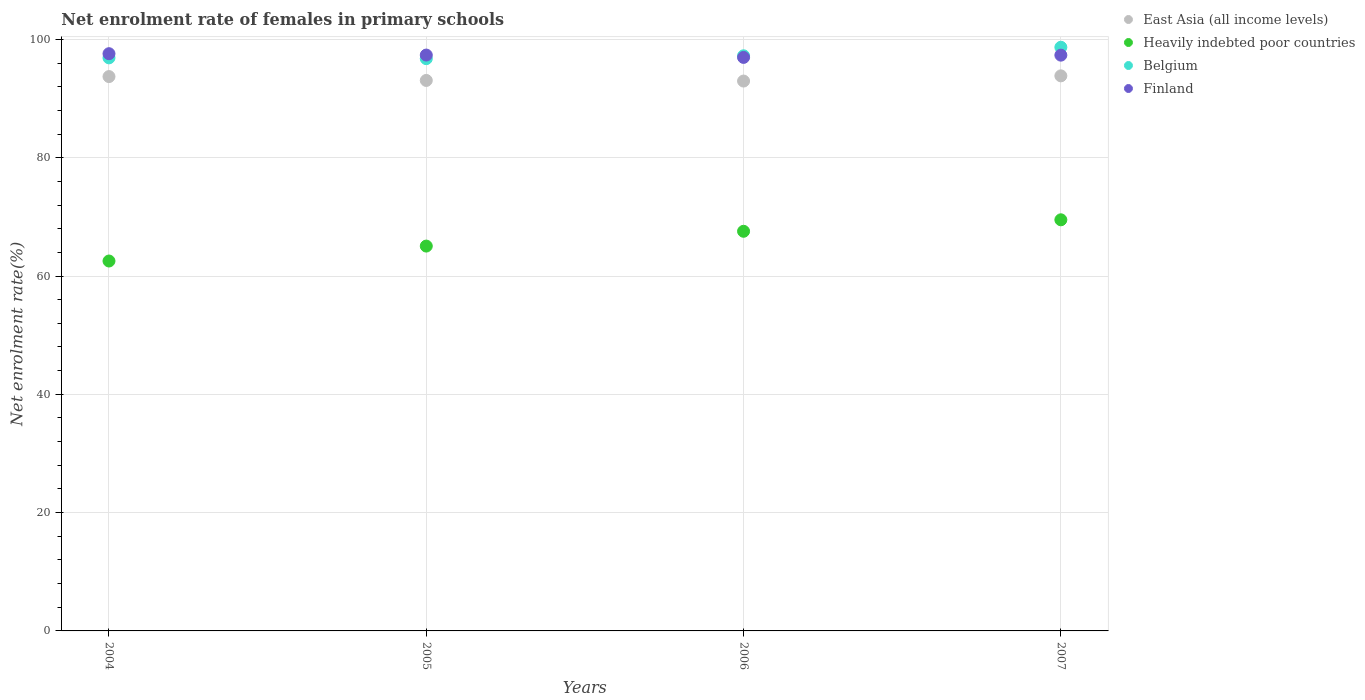What is the net enrolment rate of females in primary schools in East Asia (all income levels) in 2006?
Your response must be concise. 92.96. Across all years, what is the maximum net enrolment rate of females in primary schools in Finland?
Your response must be concise. 97.58. Across all years, what is the minimum net enrolment rate of females in primary schools in Belgium?
Your answer should be very brief. 96.75. In which year was the net enrolment rate of females in primary schools in East Asia (all income levels) maximum?
Ensure brevity in your answer.  2007. In which year was the net enrolment rate of females in primary schools in East Asia (all income levels) minimum?
Give a very brief answer. 2006. What is the total net enrolment rate of females in primary schools in East Asia (all income levels) in the graph?
Give a very brief answer. 373.57. What is the difference between the net enrolment rate of females in primary schools in Heavily indebted poor countries in 2004 and that in 2006?
Provide a short and direct response. -5.03. What is the difference between the net enrolment rate of females in primary schools in Belgium in 2006 and the net enrolment rate of females in primary schools in East Asia (all income levels) in 2005?
Offer a very short reply. 4.17. What is the average net enrolment rate of females in primary schools in East Asia (all income levels) per year?
Offer a very short reply. 93.39. In the year 2005, what is the difference between the net enrolment rate of females in primary schools in Belgium and net enrolment rate of females in primary schools in East Asia (all income levels)?
Give a very brief answer. 3.68. What is the ratio of the net enrolment rate of females in primary schools in Finland in 2004 to that in 2007?
Ensure brevity in your answer.  1. What is the difference between the highest and the second highest net enrolment rate of females in primary schools in Belgium?
Keep it short and to the point. 1.44. What is the difference between the highest and the lowest net enrolment rate of females in primary schools in East Asia (all income levels)?
Your answer should be compact. 0.88. Is it the case that in every year, the sum of the net enrolment rate of females in primary schools in East Asia (all income levels) and net enrolment rate of females in primary schools in Heavily indebted poor countries  is greater than the sum of net enrolment rate of females in primary schools in Belgium and net enrolment rate of females in primary schools in Finland?
Your answer should be compact. No. Is it the case that in every year, the sum of the net enrolment rate of females in primary schools in Belgium and net enrolment rate of females in primary schools in East Asia (all income levels)  is greater than the net enrolment rate of females in primary schools in Finland?
Your answer should be compact. Yes. How many years are there in the graph?
Your answer should be compact. 4. What is the difference between two consecutive major ticks on the Y-axis?
Provide a succinct answer. 20. Are the values on the major ticks of Y-axis written in scientific E-notation?
Ensure brevity in your answer.  No. Does the graph contain grids?
Offer a terse response. Yes. What is the title of the graph?
Provide a succinct answer. Net enrolment rate of females in primary schools. What is the label or title of the X-axis?
Your answer should be compact. Years. What is the label or title of the Y-axis?
Offer a terse response. Net enrolment rate(%). What is the Net enrolment rate(%) in East Asia (all income levels) in 2004?
Offer a very short reply. 93.72. What is the Net enrolment rate(%) of Heavily indebted poor countries in 2004?
Provide a short and direct response. 62.54. What is the Net enrolment rate(%) in Belgium in 2004?
Provide a short and direct response. 96.88. What is the Net enrolment rate(%) of Finland in 2004?
Your answer should be very brief. 97.58. What is the Net enrolment rate(%) of East Asia (all income levels) in 2005?
Provide a short and direct response. 93.06. What is the Net enrolment rate(%) in Heavily indebted poor countries in 2005?
Give a very brief answer. 65.06. What is the Net enrolment rate(%) of Belgium in 2005?
Your answer should be compact. 96.75. What is the Net enrolment rate(%) of Finland in 2005?
Give a very brief answer. 97.35. What is the Net enrolment rate(%) of East Asia (all income levels) in 2006?
Your response must be concise. 92.96. What is the Net enrolment rate(%) of Heavily indebted poor countries in 2006?
Your response must be concise. 67.56. What is the Net enrolment rate(%) in Belgium in 2006?
Offer a terse response. 97.23. What is the Net enrolment rate(%) of Finland in 2006?
Your answer should be compact. 96.96. What is the Net enrolment rate(%) of East Asia (all income levels) in 2007?
Offer a terse response. 93.84. What is the Net enrolment rate(%) in Heavily indebted poor countries in 2007?
Keep it short and to the point. 69.5. What is the Net enrolment rate(%) in Belgium in 2007?
Your response must be concise. 98.67. What is the Net enrolment rate(%) in Finland in 2007?
Your answer should be compact. 97.34. Across all years, what is the maximum Net enrolment rate(%) of East Asia (all income levels)?
Provide a succinct answer. 93.84. Across all years, what is the maximum Net enrolment rate(%) in Heavily indebted poor countries?
Your response must be concise. 69.5. Across all years, what is the maximum Net enrolment rate(%) in Belgium?
Ensure brevity in your answer.  98.67. Across all years, what is the maximum Net enrolment rate(%) of Finland?
Offer a terse response. 97.58. Across all years, what is the minimum Net enrolment rate(%) in East Asia (all income levels)?
Your response must be concise. 92.96. Across all years, what is the minimum Net enrolment rate(%) in Heavily indebted poor countries?
Your response must be concise. 62.54. Across all years, what is the minimum Net enrolment rate(%) in Belgium?
Offer a terse response. 96.75. Across all years, what is the minimum Net enrolment rate(%) of Finland?
Keep it short and to the point. 96.96. What is the total Net enrolment rate(%) of East Asia (all income levels) in the graph?
Keep it short and to the point. 373.57. What is the total Net enrolment rate(%) in Heavily indebted poor countries in the graph?
Provide a short and direct response. 264.66. What is the total Net enrolment rate(%) of Belgium in the graph?
Your answer should be very brief. 389.53. What is the total Net enrolment rate(%) in Finland in the graph?
Offer a very short reply. 389.23. What is the difference between the Net enrolment rate(%) of East Asia (all income levels) in 2004 and that in 2005?
Offer a terse response. 0.65. What is the difference between the Net enrolment rate(%) in Heavily indebted poor countries in 2004 and that in 2005?
Your answer should be very brief. -2.52. What is the difference between the Net enrolment rate(%) in Belgium in 2004 and that in 2005?
Your answer should be compact. 0.13. What is the difference between the Net enrolment rate(%) of Finland in 2004 and that in 2005?
Provide a short and direct response. 0.23. What is the difference between the Net enrolment rate(%) in East Asia (all income levels) in 2004 and that in 2006?
Offer a very short reply. 0.76. What is the difference between the Net enrolment rate(%) of Heavily indebted poor countries in 2004 and that in 2006?
Keep it short and to the point. -5.03. What is the difference between the Net enrolment rate(%) of Belgium in 2004 and that in 2006?
Offer a very short reply. -0.35. What is the difference between the Net enrolment rate(%) of Finland in 2004 and that in 2006?
Provide a short and direct response. 0.63. What is the difference between the Net enrolment rate(%) in East Asia (all income levels) in 2004 and that in 2007?
Provide a short and direct response. -0.12. What is the difference between the Net enrolment rate(%) of Heavily indebted poor countries in 2004 and that in 2007?
Offer a very short reply. -6.97. What is the difference between the Net enrolment rate(%) in Belgium in 2004 and that in 2007?
Offer a very short reply. -1.79. What is the difference between the Net enrolment rate(%) of Finland in 2004 and that in 2007?
Make the answer very short. 0.25. What is the difference between the Net enrolment rate(%) of East Asia (all income levels) in 2005 and that in 2006?
Ensure brevity in your answer.  0.1. What is the difference between the Net enrolment rate(%) of Heavily indebted poor countries in 2005 and that in 2006?
Provide a succinct answer. -2.5. What is the difference between the Net enrolment rate(%) in Belgium in 2005 and that in 2006?
Provide a succinct answer. -0.48. What is the difference between the Net enrolment rate(%) in Finland in 2005 and that in 2006?
Ensure brevity in your answer.  0.4. What is the difference between the Net enrolment rate(%) in East Asia (all income levels) in 2005 and that in 2007?
Give a very brief answer. -0.78. What is the difference between the Net enrolment rate(%) in Heavily indebted poor countries in 2005 and that in 2007?
Your answer should be very brief. -4.44. What is the difference between the Net enrolment rate(%) in Belgium in 2005 and that in 2007?
Provide a succinct answer. -1.93. What is the difference between the Net enrolment rate(%) in Finland in 2005 and that in 2007?
Your response must be concise. 0.02. What is the difference between the Net enrolment rate(%) of East Asia (all income levels) in 2006 and that in 2007?
Your answer should be very brief. -0.88. What is the difference between the Net enrolment rate(%) in Heavily indebted poor countries in 2006 and that in 2007?
Offer a terse response. -1.94. What is the difference between the Net enrolment rate(%) of Belgium in 2006 and that in 2007?
Your response must be concise. -1.44. What is the difference between the Net enrolment rate(%) in Finland in 2006 and that in 2007?
Offer a terse response. -0.38. What is the difference between the Net enrolment rate(%) in East Asia (all income levels) in 2004 and the Net enrolment rate(%) in Heavily indebted poor countries in 2005?
Your answer should be very brief. 28.65. What is the difference between the Net enrolment rate(%) of East Asia (all income levels) in 2004 and the Net enrolment rate(%) of Belgium in 2005?
Offer a terse response. -3.03. What is the difference between the Net enrolment rate(%) of East Asia (all income levels) in 2004 and the Net enrolment rate(%) of Finland in 2005?
Your answer should be compact. -3.64. What is the difference between the Net enrolment rate(%) in Heavily indebted poor countries in 2004 and the Net enrolment rate(%) in Belgium in 2005?
Your answer should be compact. -34.21. What is the difference between the Net enrolment rate(%) in Heavily indebted poor countries in 2004 and the Net enrolment rate(%) in Finland in 2005?
Provide a short and direct response. -34.82. What is the difference between the Net enrolment rate(%) in Belgium in 2004 and the Net enrolment rate(%) in Finland in 2005?
Your answer should be compact. -0.47. What is the difference between the Net enrolment rate(%) of East Asia (all income levels) in 2004 and the Net enrolment rate(%) of Heavily indebted poor countries in 2006?
Provide a short and direct response. 26.15. What is the difference between the Net enrolment rate(%) of East Asia (all income levels) in 2004 and the Net enrolment rate(%) of Belgium in 2006?
Give a very brief answer. -3.51. What is the difference between the Net enrolment rate(%) in East Asia (all income levels) in 2004 and the Net enrolment rate(%) in Finland in 2006?
Offer a terse response. -3.24. What is the difference between the Net enrolment rate(%) in Heavily indebted poor countries in 2004 and the Net enrolment rate(%) in Belgium in 2006?
Offer a terse response. -34.69. What is the difference between the Net enrolment rate(%) in Heavily indebted poor countries in 2004 and the Net enrolment rate(%) in Finland in 2006?
Your answer should be compact. -34.42. What is the difference between the Net enrolment rate(%) of Belgium in 2004 and the Net enrolment rate(%) of Finland in 2006?
Make the answer very short. -0.08. What is the difference between the Net enrolment rate(%) in East Asia (all income levels) in 2004 and the Net enrolment rate(%) in Heavily indebted poor countries in 2007?
Ensure brevity in your answer.  24.21. What is the difference between the Net enrolment rate(%) of East Asia (all income levels) in 2004 and the Net enrolment rate(%) of Belgium in 2007?
Give a very brief answer. -4.96. What is the difference between the Net enrolment rate(%) in East Asia (all income levels) in 2004 and the Net enrolment rate(%) in Finland in 2007?
Make the answer very short. -3.62. What is the difference between the Net enrolment rate(%) in Heavily indebted poor countries in 2004 and the Net enrolment rate(%) in Belgium in 2007?
Give a very brief answer. -36.14. What is the difference between the Net enrolment rate(%) of Heavily indebted poor countries in 2004 and the Net enrolment rate(%) of Finland in 2007?
Offer a very short reply. -34.8. What is the difference between the Net enrolment rate(%) in Belgium in 2004 and the Net enrolment rate(%) in Finland in 2007?
Your answer should be compact. -0.46. What is the difference between the Net enrolment rate(%) of East Asia (all income levels) in 2005 and the Net enrolment rate(%) of Heavily indebted poor countries in 2006?
Keep it short and to the point. 25.5. What is the difference between the Net enrolment rate(%) in East Asia (all income levels) in 2005 and the Net enrolment rate(%) in Belgium in 2006?
Your answer should be compact. -4.17. What is the difference between the Net enrolment rate(%) of East Asia (all income levels) in 2005 and the Net enrolment rate(%) of Finland in 2006?
Keep it short and to the point. -3.89. What is the difference between the Net enrolment rate(%) of Heavily indebted poor countries in 2005 and the Net enrolment rate(%) of Belgium in 2006?
Your answer should be compact. -32.17. What is the difference between the Net enrolment rate(%) in Heavily indebted poor countries in 2005 and the Net enrolment rate(%) in Finland in 2006?
Offer a terse response. -31.9. What is the difference between the Net enrolment rate(%) of Belgium in 2005 and the Net enrolment rate(%) of Finland in 2006?
Offer a very short reply. -0.21. What is the difference between the Net enrolment rate(%) of East Asia (all income levels) in 2005 and the Net enrolment rate(%) of Heavily indebted poor countries in 2007?
Provide a short and direct response. 23.56. What is the difference between the Net enrolment rate(%) in East Asia (all income levels) in 2005 and the Net enrolment rate(%) in Belgium in 2007?
Give a very brief answer. -5.61. What is the difference between the Net enrolment rate(%) of East Asia (all income levels) in 2005 and the Net enrolment rate(%) of Finland in 2007?
Your answer should be compact. -4.28. What is the difference between the Net enrolment rate(%) of Heavily indebted poor countries in 2005 and the Net enrolment rate(%) of Belgium in 2007?
Your answer should be very brief. -33.61. What is the difference between the Net enrolment rate(%) in Heavily indebted poor countries in 2005 and the Net enrolment rate(%) in Finland in 2007?
Offer a terse response. -32.28. What is the difference between the Net enrolment rate(%) of Belgium in 2005 and the Net enrolment rate(%) of Finland in 2007?
Offer a terse response. -0.59. What is the difference between the Net enrolment rate(%) in East Asia (all income levels) in 2006 and the Net enrolment rate(%) in Heavily indebted poor countries in 2007?
Your response must be concise. 23.46. What is the difference between the Net enrolment rate(%) in East Asia (all income levels) in 2006 and the Net enrolment rate(%) in Belgium in 2007?
Give a very brief answer. -5.71. What is the difference between the Net enrolment rate(%) in East Asia (all income levels) in 2006 and the Net enrolment rate(%) in Finland in 2007?
Keep it short and to the point. -4.38. What is the difference between the Net enrolment rate(%) of Heavily indebted poor countries in 2006 and the Net enrolment rate(%) of Belgium in 2007?
Offer a very short reply. -31.11. What is the difference between the Net enrolment rate(%) of Heavily indebted poor countries in 2006 and the Net enrolment rate(%) of Finland in 2007?
Provide a short and direct response. -29.78. What is the difference between the Net enrolment rate(%) in Belgium in 2006 and the Net enrolment rate(%) in Finland in 2007?
Provide a succinct answer. -0.11. What is the average Net enrolment rate(%) in East Asia (all income levels) per year?
Provide a short and direct response. 93.39. What is the average Net enrolment rate(%) of Heavily indebted poor countries per year?
Keep it short and to the point. 66.17. What is the average Net enrolment rate(%) in Belgium per year?
Make the answer very short. 97.38. What is the average Net enrolment rate(%) of Finland per year?
Ensure brevity in your answer.  97.31. In the year 2004, what is the difference between the Net enrolment rate(%) in East Asia (all income levels) and Net enrolment rate(%) in Heavily indebted poor countries?
Provide a short and direct response. 31.18. In the year 2004, what is the difference between the Net enrolment rate(%) in East Asia (all income levels) and Net enrolment rate(%) in Belgium?
Your answer should be compact. -3.16. In the year 2004, what is the difference between the Net enrolment rate(%) in East Asia (all income levels) and Net enrolment rate(%) in Finland?
Offer a very short reply. -3.87. In the year 2004, what is the difference between the Net enrolment rate(%) in Heavily indebted poor countries and Net enrolment rate(%) in Belgium?
Make the answer very short. -34.34. In the year 2004, what is the difference between the Net enrolment rate(%) of Heavily indebted poor countries and Net enrolment rate(%) of Finland?
Give a very brief answer. -35.05. In the year 2004, what is the difference between the Net enrolment rate(%) in Belgium and Net enrolment rate(%) in Finland?
Give a very brief answer. -0.7. In the year 2005, what is the difference between the Net enrolment rate(%) in East Asia (all income levels) and Net enrolment rate(%) in Heavily indebted poor countries?
Your response must be concise. 28. In the year 2005, what is the difference between the Net enrolment rate(%) in East Asia (all income levels) and Net enrolment rate(%) in Belgium?
Your answer should be compact. -3.68. In the year 2005, what is the difference between the Net enrolment rate(%) of East Asia (all income levels) and Net enrolment rate(%) of Finland?
Provide a short and direct response. -4.29. In the year 2005, what is the difference between the Net enrolment rate(%) in Heavily indebted poor countries and Net enrolment rate(%) in Belgium?
Provide a succinct answer. -31.69. In the year 2005, what is the difference between the Net enrolment rate(%) in Heavily indebted poor countries and Net enrolment rate(%) in Finland?
Provide a short and direct response. -32.29. In the year 2005, what is the difference between the Net enrolment rate(%) of Belgium and Net enrolment rate(%) of Finland?
Provide a succinct answer. -0.61. In the year 2006, what is the difference between the Net enrolment rate(%) of East Asia (all income levels) and Net enrolment rate(%) of Heavily indebted poor countries?
Keep it short and to the point. 25.4. In the year 2006, what is the difference between the Net enrolment rate(%) in East Asia (all income levels) and Net enrolment rate(%) in Belgium?
Your response must be concise. -4.27. In the year 2006, what is the difference between the Net enrolment rate(%) of East Asia (all income levels) and Net enrolment rate(%) of Finland?
Your answer should be very brief. -4. In the year 2006, what is the difference between the Net enrolment rate(%) in Heavily indebted poor countries and Net enrolment rate(%) in Belgium?
Give a very brief answer. -29.67. In the year 2006, what is the difference between the Net enrolment rate(%) of Heavily indebted poor countries and Net enrolment rate(%) of Finland?
Ensure brevity in your answer.  -29.39. In the year 2006, what is the difference between the Net enrolment rate(%) in Belgium and Net enrolment rate(%) in Finland?
Provide a short and direct response. 0.27. In the year 2007, what is the difference between the Net enrolment rate(%) of East Asia (all income levels) and Net enrolment rate(%) of Heavily indebted poor countries?
Keep it short and to the point. 24.34. In the year 2007, what is the difference between the Net enrolment rate(%) of East Asia (all income levels) and Net enrolment rate(%) of Belgium?
Provide a succinct answer. -4.83. In the year 2007, what is the difference between the Net enrolment rate(%) in East Asia (all income levels) and Net enrolment rate(%) in Finland?
Your answer should be compact. -3.5. In the year 2007, what is the difference between the Net enrolment rate(%) of Heavily indebted poor countries and Net enrolment rate(%) of Belgium?
Your answer should be compact. -29.17. In the year 2007, what is the difference between the Net enrolment rate(%) in Heavily indebted poor countries and Net enrolment rate(%) in Finland?
Offer a terse response. -27.83. In the year 2007, what is the difference between the Net enrolment rate(%) of Belgium and Net enrolment rate(%) of Finland?
Your response must be concise. 1.33. What is the ratio of the Net enrolment rate(%) in East Asia (all income levels) in 2004 to that in 2005?
Provide a succinct answer. 1.01. What is the ratio of the Net enrolment rate(%) in Heavily indebted poor countries in 2004 to that in 2005?
Ensure brevity in your answer.  0.96. What is the ratio of the Net enrolment rate(%) of Finland in 2004 to that in 2005?
Your answer should be compact. 1. What is the ratio of the Net enrolment rate(%) in Heavily indebted poor countries in 2004 to that in 2006?
Keep it short and to the point. 0.93. What is the ratio of the Net enrolment rate(%) in Belgium in 2004 to that in 2006?
Give a very brief answer. 1. What is the ratio of the Net enrolment rate(%) in Heavily indebted poor countries in 2004 to that in 2007?
Your response must be concise. 0.9. What is the ratio of the Net enrolment rate(%) of Belgium in 2004 to that in 2007?
Give a very brief answer. 0.98. What is the ratio of the Net enrolment rate(%) of Finland in 2004 to that in 2007?
Offer a terse response. 1. What is the ratio of the Net enrolment rate(%) in Finland in 2005 to that in 2006?
Ensure brevity in your answer.  1. What is the ratio of the Net enrolment rate(%) in East Asia (all income levels) in 2005 to that in 2007?
Make the answer very short. 0.99. What is the ratio of the Net enrolment rate(%) in Heavily indebted poor countries in 2005 to that in 2007?
Your response must be concise. 0.94. What is the ratio of the Net enrolment rate(%) of Belgium in 2005 to that in 2007?
Provide a short and direct response. 0.98. What is the ratio of the Net enrolment rate(%) of East Asia (all income levels) in 2006 to that in 2007?
Ensure brevity in your answer.  0.99. What is the ratio of the Net enrolment rate(%) of Heavily indebted poor countries in 2006 to that in 2007?
Offer a very short reply. 0.97. What is the ratio of the Net enrolment rate(%) of Belgium in 2006 to that in 2007?
Keep it short and to the point. 0.99. What is the difference between the highest and the second highest Net enrolment rate(%) of East Asia (all income levels)?
Offer a very short reply. 0.12. What is the difference between the highest and the second highest Net enrolment rate(%) in Heavily indebted poor countries?
Provide a succinct answer. 1.94. What is the difference between the highest and the second highest Net enrolment rate(%) of Belgium?
Your answer should be very brief. 1.44. What is the difference between the highest and the second highest Net enrolment rate(%) of Finland?
Ensure brevity in your answer.  0.23. What is the difference between the highest and the lowest Net enrolment rate(%) in East Asia (all income levels)?
Your answer should be very brief. 0.88. What is the difference between the highest and the lowest Net enrolment rate(%) in Heavily indebted poor countries?
Ensure brevity in your answer.  6.97. What is the difference between the highest and the lowest Net enrolment rate(%) in Belgium?
Make the answer very short. 1.93. What is the difference between the highest and the lowest Net enrolment rate(%) of Finland?
Your response must be concise. 0.63. 